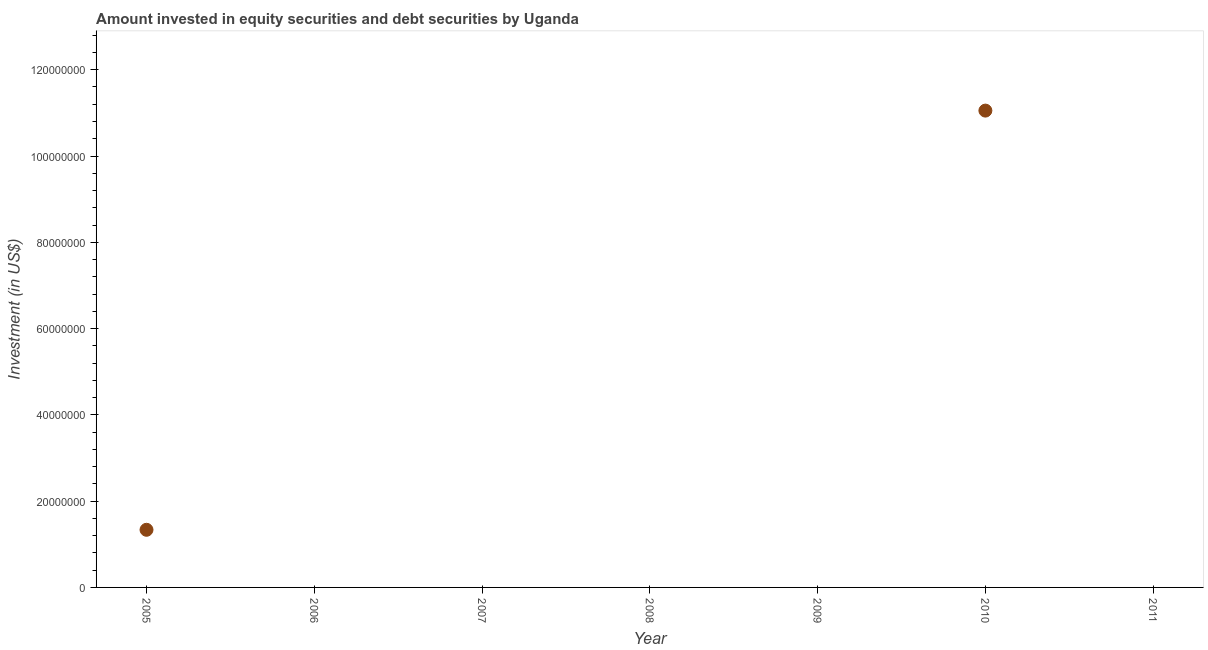What is the portfolio investment in 2006?
Keep it short and to the point. 0. Across all years, what is the maximum portfolio investment?
Offer a terse response. 1.11e+08. In which year was the portfolio investment maximum?
Your answer should be compact. 2010. What is the sum of the portfolio investment?
Give a very brief answer. 1.24e+08. What is the average portfolio investment per year?
Offer a very short reply. 1.77e+07. In how many years, is the portfolio investment greater than 52000000 US$?
Give a very brief answer. 1. What is the ratio of the portfolio investment in 2005 to that in 2010?
Provide a short and direct response. 0.12. Is the portfolio investment in 2005 less than that in 2010?
Ensure brevity in your answer.  Yes. What is the difference between the highest and the lowest portfolio investment?
Your answer should be very brief. 1.11e+08. Does the portfolio investment monotonically increase over the years?
Offer a very short reply. No. How many years are there in the graph?
Keep it short and to the point. 7. What is the difference between two consecutive major ticks on the Y-axis?
Your answer should be compact. 2.00e+07. Does the graph contain any zero values?
Make the answer very short. Yes. Does the graph contain grids?
Give a very brief answer. No. What is the title of the graph?
Your answer should be very brief. Amount invested in equity securities and debt securities by Uganda. What is the label or title of the Y-axis?
Ensure brevity in your answer.  Investment (in US$). What is the Investment (in US$) in 2005?
Provide a short and direct response. 1.34e+07. What is the Investment (in US$) in 2006?
Give a very brief answer. 0. What is the Investment (in US$) in 2007?
Give a very brief answer. 0. What is the Investment (in US$) in 2010?
Keep it short and to the point. 1.11e+08. What is the Investment (in US$) in 2011?
Make the answer very short. 0. What is the difference between the Investment (in US$) in 2005 and 2010?
Make the answer very short. -9.72e+07. What is the ratio of the Investment (in US$) in 2005 to that in 2010?
Provide a short and direct response. 0.12. 